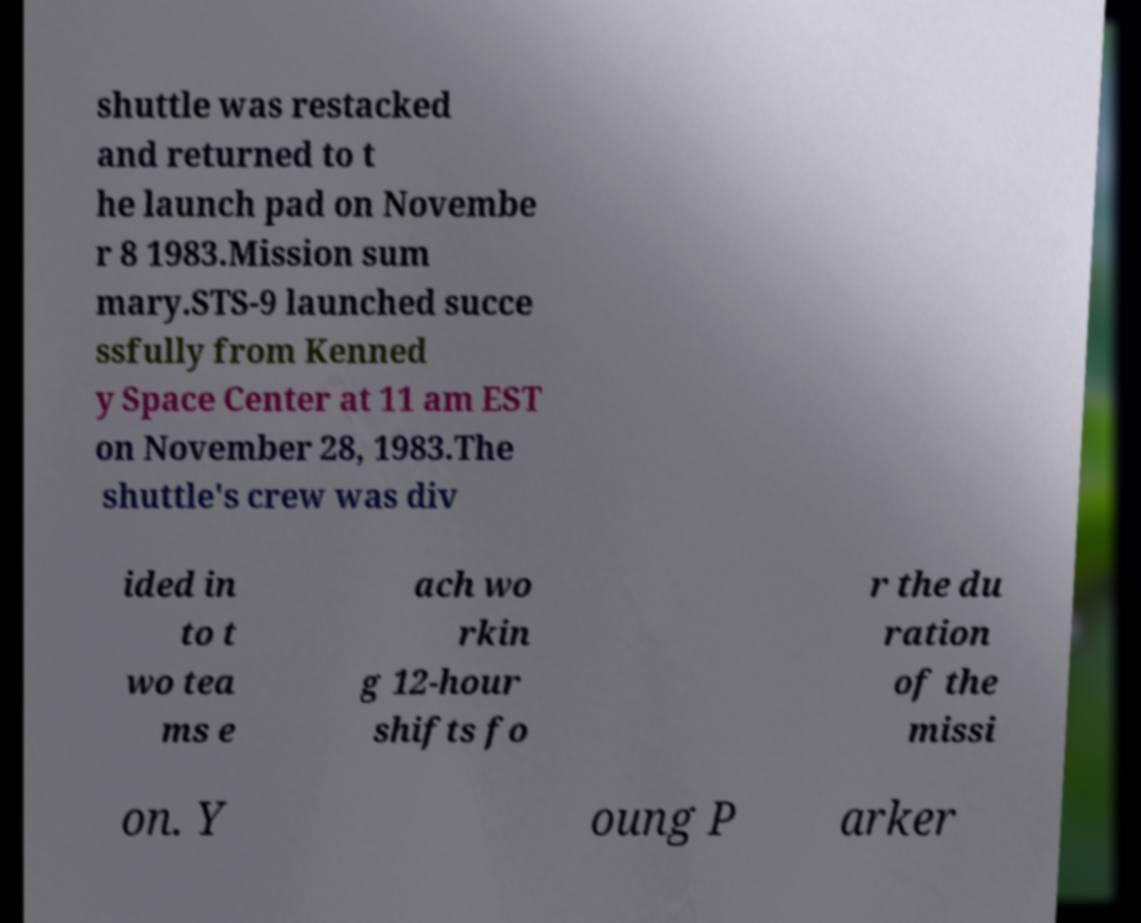For documentation purposes, I need the text within this image transcribed. Could you provide that? shuttle was restacked and returned to t he launch pad on Novembe r 8 1983.Mission sum mary.STS-9 launched succe ssfully from Kenned y Space Center at 11 am EST on November 28, 1983.The shuttle's crew was div ided in to t wo tea ms e ach wo rkin g 12-hour shifts fo r the du ration of the missi on. Y oung P arker 